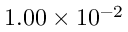<formula> <loc_0><loc_0><loc_500><loc_500>1 . 0 0 \times 1 0 ^ { - 2 }</formula> 